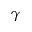<formula> <loc_0><loc_0><loc_500><loc_500>\gamma</formula> 